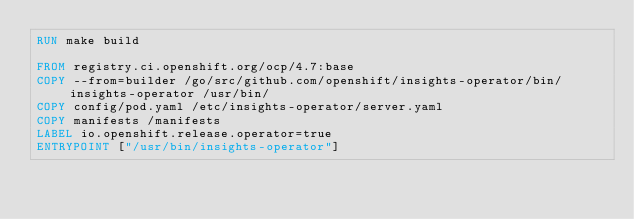Convert code to text. <code><loc_0><loc_0><loc_500><loc_500><_Dockerfile_>RUN make build

FROM registry.ci.openshift.org/ocp/4.7:base
COPY --from=builder /go/src/github.com/openshift/insights-operator/bin/insights-operator /usr/bin/
COPY config/pod.yaml /etc/insights-operator/server.yaml
COPY manifests /manifests
LABEL io.openshift.release.operator=true
ENTRYPOINT ["/usr/bin/insights-operator"]
</code> 